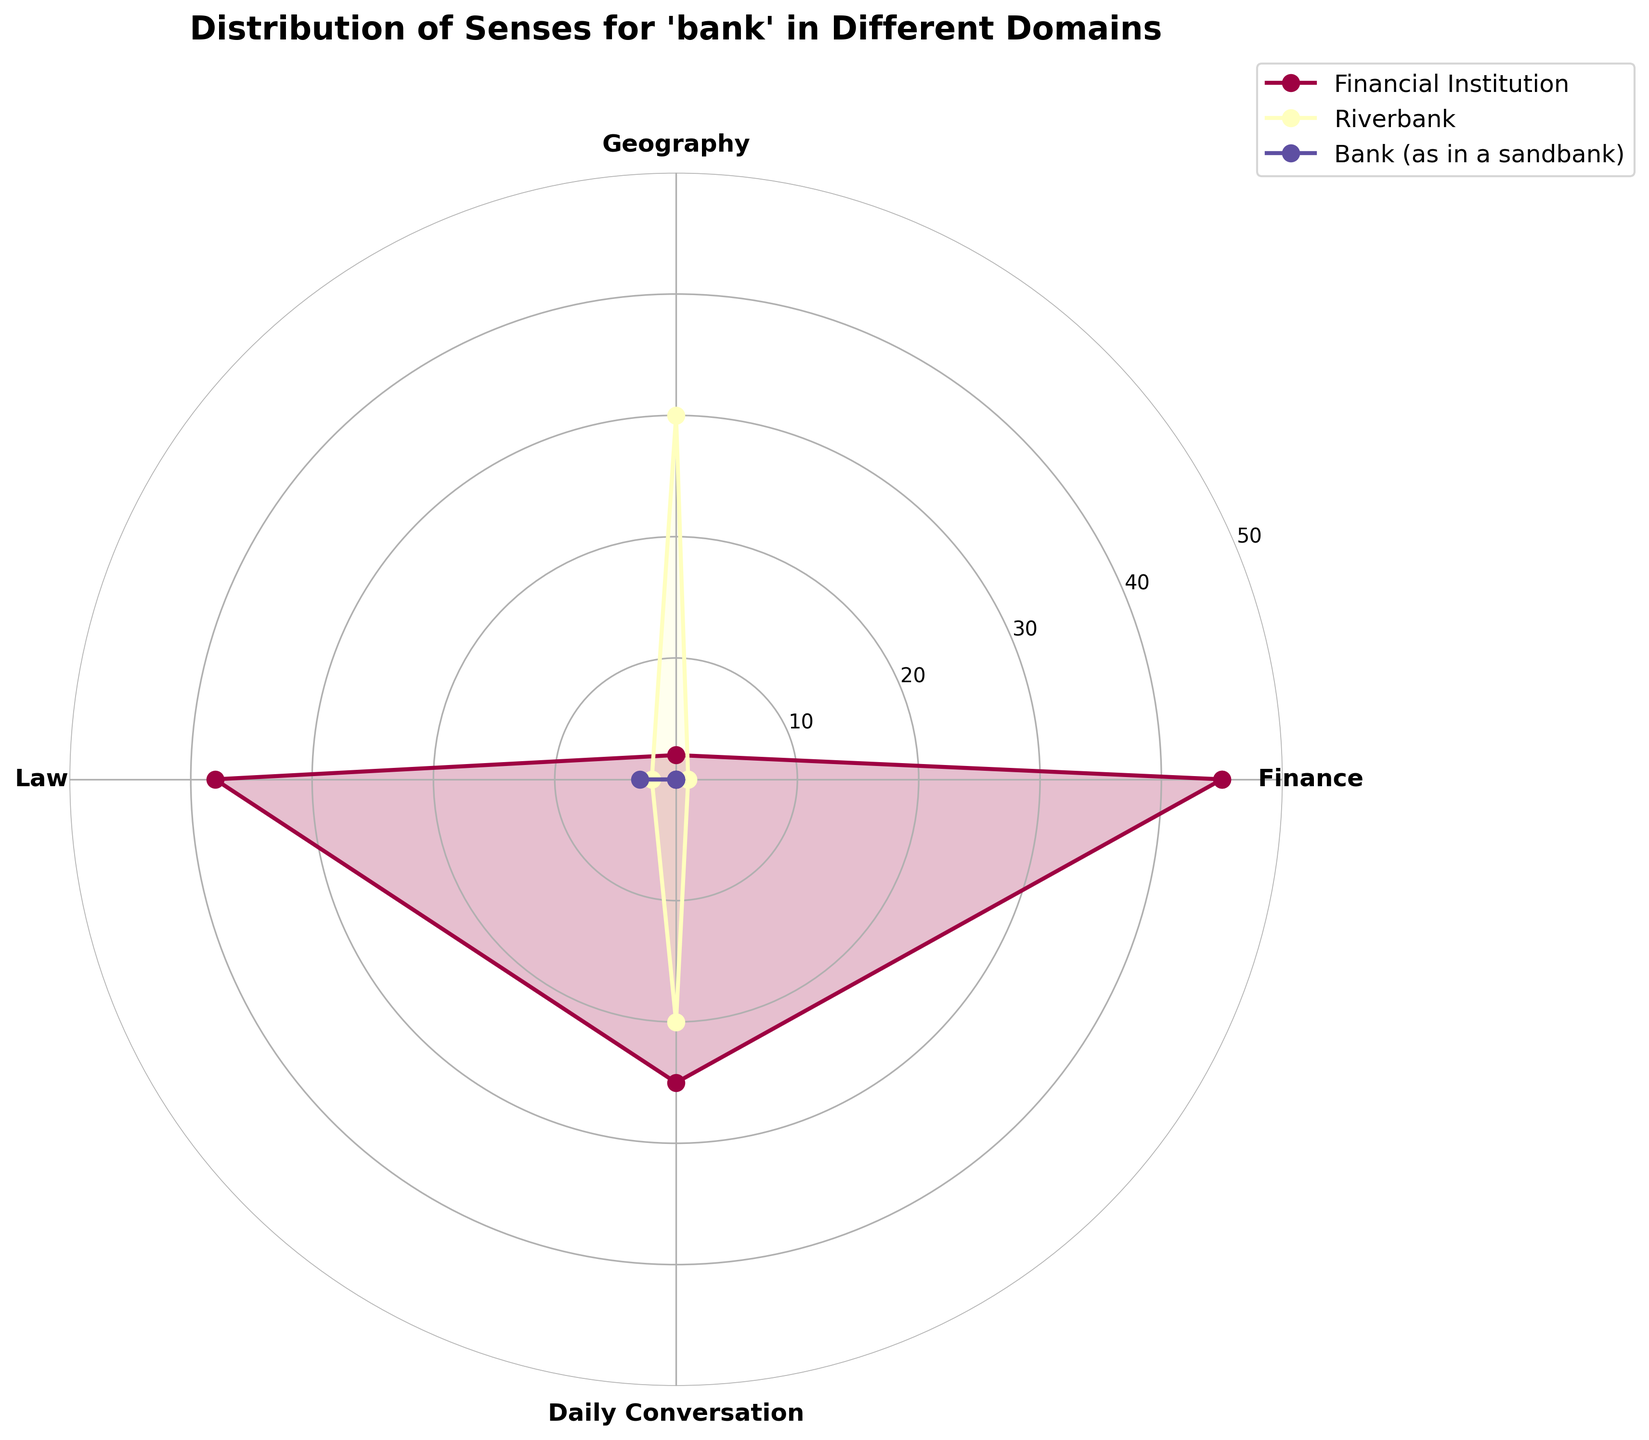Which domain uses the sense 'Financial Institution' the most? Look for the section with the largest value in the sense 'Financial Institution' and find the corresponding domain. The sector in Finance shows the highest radius for 'Financial Institution'.
Answer: Finance What is the combined frequency of the sense 'Riverbank' in Geography and Daily Conversation? Identify and sum the values for 'Riverbank' in Geography and Daily Conversation domains. Geography has 30, Daily Conversation has 20. Total is 30 + 20 = 50.
Answer: 50 How does the frequency of 'Riverbank' in Finance compare to that in Law? Identify and compare the values of 'Riverbank' in Finance and Law domains. Finance has 1, Law has 2.
Answer: Law > Finance What is the title of the figure? Look at the top center area of the plot for the title. It reads "Distribution of Senses for 'bank' in Different Domains".
Answer: Distribution of Senses for 'bank' in Different Domains Which sense is the least frequent across all domains? Compare the combined frequencies of all senses to identify the least frequent. 'Bank (as in a sandbank)' occurs only 3 times, making it the least frequent.
Answer: Bank (as in a sandbank) In which domain is the sense 'Riverbank' used more frequently than 'Financial Institution'? Check the domains where 'Riverbank' values are higher than 'Financial Institution'. In Geography, 'Riverbank' (30) is higher than 'Financial Institution' (2).
Answer: Geography What is the range of frequencies for 'Financial Institution' across all domains? Note the highest and lowest values for 'Financial Institution' and calculate the difference. The highest is 45 (Finance) and the lowest is 2 (Geography), so the range is 45 - 2 = 43.
Answer: 43 Which sense appears solely in the Law domain? Identify the sense that appears only in the Law domain but no other. 'Bank (as in a sandbank)' is only found in Law.
Answer: Bank (as in a sandbank) 